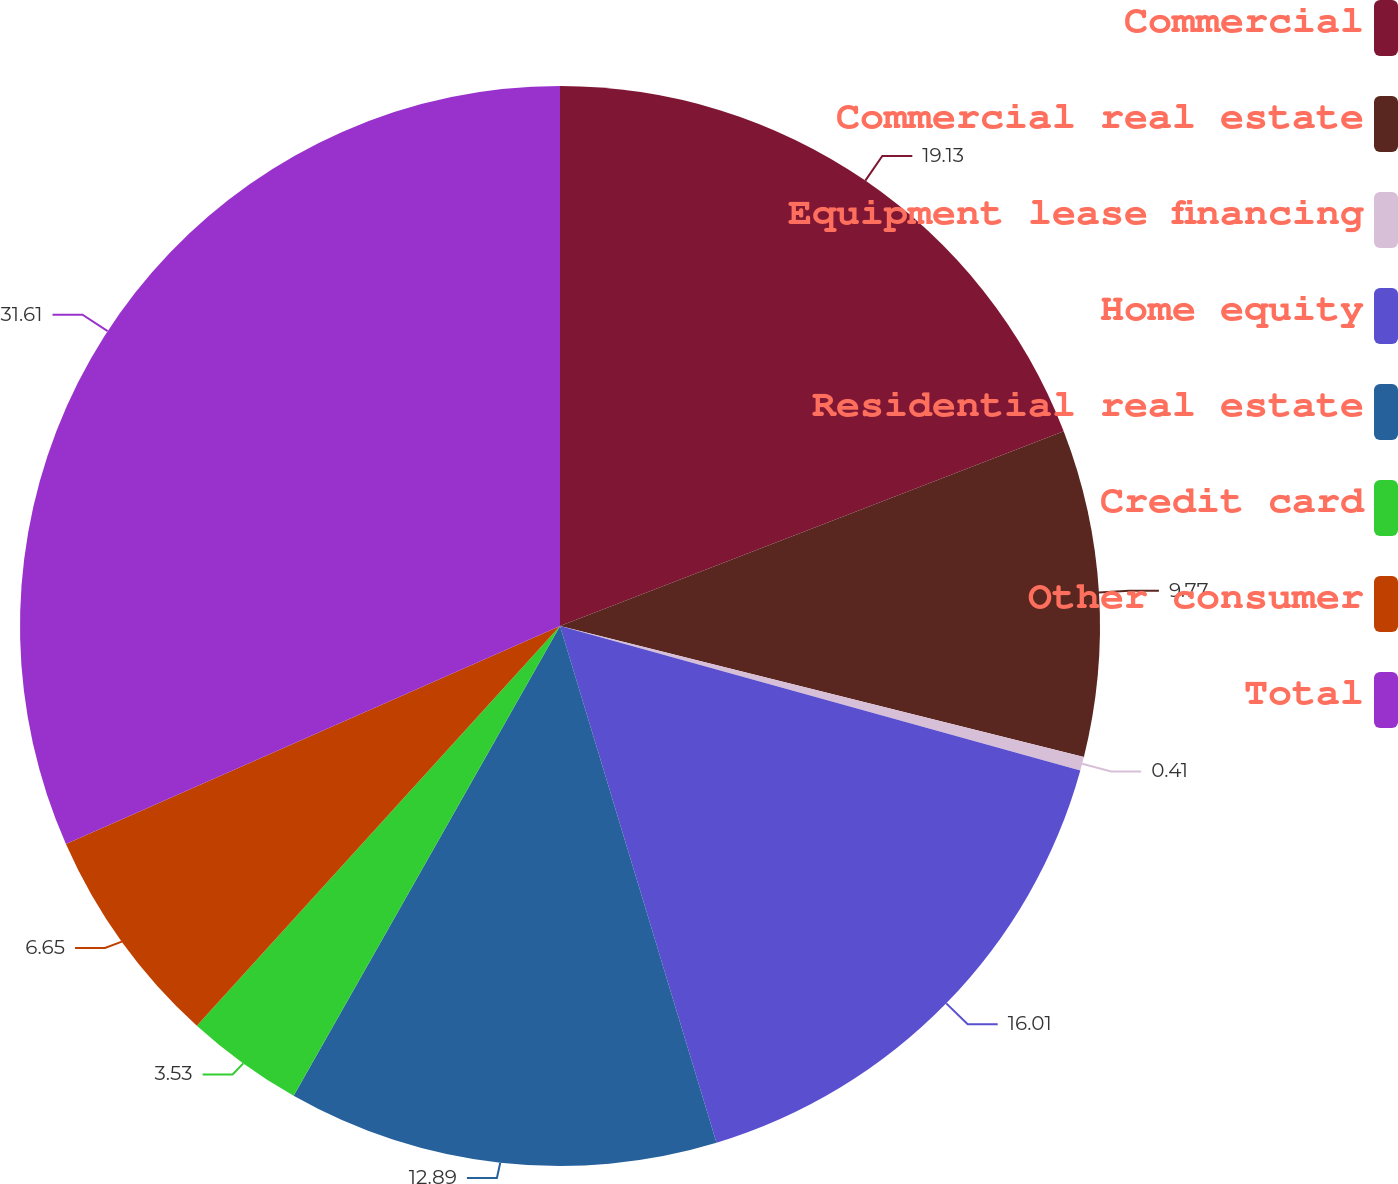<chart> <loc_0><loc_0><loc_500><loc_500><pie_chart><fcel>Commercial<fcel>Commercial real estate<fcel>Equipment lease financing<fcel>Home equity<fcel>Residential real estate<fcel>Credit card<fcel>Other consumer<fcel>Total<nl><fcel>19.13%<fcel>9.77%<fcel>0.41%<fcel>16.01%<fcel>12.89%<fcel>3.53%<fcel>6.65%<fcel>31.61%<nl></chart> 